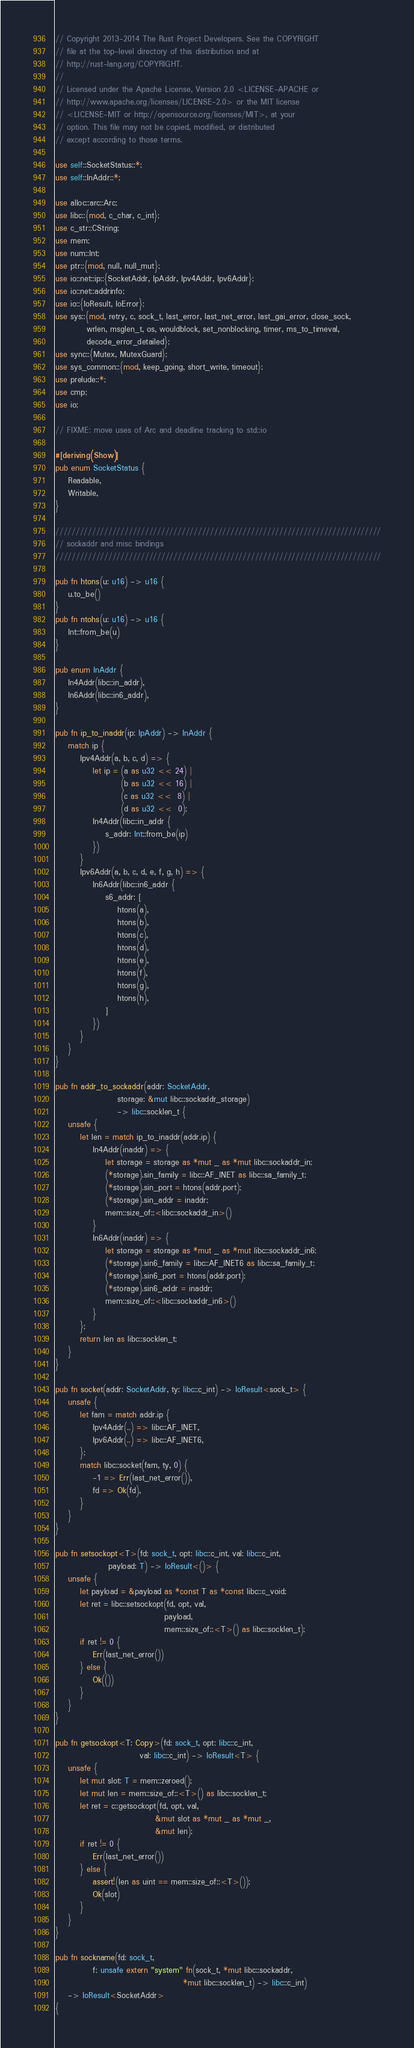<code> <loc_0><loc_0><loc_500><loc_500><_Rust_>// Copyright 2013-2014 The Rust Project Developers. See the COPYRIGHT
// file at the top-level directory of this distribution and at
// http://rust-lang.org/COPYRIGHT.
//
// Licensed under the Apache License, Version 2.0 <LICENSE-APACHE or
// http://www.apache.org/licenses/LICENSE-2.0> or the MIT license
// <LICENSE-MIT or http://opensource.org/licenses/MIT>, at your
// option. This file may not be copied, modified, or distributed
// except according to those terms.

use self::SocketStatus::*;
use self::InAddr::*;

use alloc::arc::Arc;
use libc::{mod, c_char, c_int};
use c_str::CString;
use mem;
use num::Int;
use ptr::{mod, null, null_mut};
use io::net::ip::{SocketAddr, IpAddr, Ipv4Addr, Ipv6Addr};
use io::net::addrinfo;
use io::{IoResult, IoError};
use sys::{mod, retry, c, sock_t, last_error, last_net_error, last_gai_error, close_sock,
          wrlen, msglen_t, os, wouldblock, set_nonblocking, timer, ms_to_timeval,
          decode_error_detailed};
use sync::{Mutex, MutexGuard};
use sys_common::{mod, keep_going, short_write, timeout};
use prelude::*;
use cmp;
use io;

// FIXME: move uses of Arc and deadline tracking to std::io

#[deriving(Show)]
pub enum SocketStatus {
    Readable,
    Writable,
}

////////////////////////////////////////////////////////////////////////////////
// sockaddr and misc bindings
////////////////////////////////////////////////////////////////////////////////

pub fn htons(u: u16) -> u16 {
    u.to_be()
}
pub fn ntohs(u: u16) -> u16 {
    Int::from_be(u)
}

pub enum InAddr {
    In4Addr(libc::in_addr),
    In6Addr(libc::in6_addr),
}

pub fn ip_to_inaddr(ip: IpAddr) -> InAddr {
    match ip {
        Ipv4Addr(a, b, c, d) => {
            let ip = (a as u32 << 24) |
                     (b as u32 << 16) |
                     (c as u32 <<  8) |
                     (d as u32 <<  0);
            In4Addr(libc::in_addr {
                s_addr: Int::from_be(ip)
            })
        }
        Ipv6Addr(a, b, c, d, e, f, g, h) => {
            In6Addr(libc::in6_addr {
                s6_addr: [
                    htons(a),
                    htons(b),
                    htons(c),
                    htons(d),
                    htons(e),
                    htons(f),
                    htons(g),
                    htons(h),
                ]
            })
        }
    }
}

pub fn addr_to_sockaddr(addr: SocketAddr,
                    storage: &mut libc::sockaddr_storage)
                    -> libc::socklen_t {
    unsafe {
        let len = match ip_to_inaddr(addr.ip) {
            In4Addr(inaddr) => {
                let storage = storage as *mut _ as *mut libc::sockaddr_in;
                (*storage).sin_family = libc::AF_INET as libc::sa_family_t;
                (*storage).sin_port = htons(addr.port);
                (*storage).sin_addr = inaddr;
                mem::size_of::<libc::sockaddr_in>()
            }
            In6Addr(inaddr) => {
                let storage = storage as *mut _ as *mut libc::sockaddr_in6;
                (*storage).sin6_family = libc::AF_INET6 as libc::sa_family_t;
                (*storage).sin6_port = htons(addr.port);
                (*storage).sin6_addr = inaddr;
                mem::size_of::<libc::sockaddr_in6>()
            }
        };
        return len as libc::socklen_t;
    }
}

pub fn socket(addr: SocketAddr, ty: libc::c_int) -> IoResult<sock_t> {
    unsafe {
        let fam = match addr.ip {
            Ipv4Addr(..) => libc::AF_INET,
            Ipv6Addr(..) => libc::AF_INET6,
        };
        match libc::socket(fam, ty, 0) {
            -1 => Err(last_net_error()),
            fd => Ok(fd),
        }
    }
}

pub fn setsockopt<T>(fd: sock_t, opt: libc::c_int, val: libc::c_int,
                 payload: T) -> IoResult<()> {
    unsafe {
        let payload = &payload as *const T as *const libc::c_void;
        let ret = libc::setsockopt(fd, opt, val,
                                   payload,
                                   mem::size_of::<T>() as libc::socklen_t);
        if ret != 0 {
            Err(last_net_error())
        } else {
            Ok(())
        }
    }
}

pub fn getsockopt<T: Copy>(fd: sock_t, opt: libc::c_int,
                           val: libc::c_int) -> IoResult<T> {
    unsafe {
        let mut slot: T = mem::zeroed();
        let mut len = mem::size_of::<T>() as libc::socklen_t;
        let ret = c::getsockopt(fd, opt, val,
                                &mut slot as *mut _ as *mut _,
                                &mut len);
        if ret != 0 {
            Err(last_net_error())
        } else {
            assert!(len as uint == mem::size_of::<T>());
            Ok(slot)
        }
    }
}

pub fn sockname(fd: sock_t,
            f: unsafe extern "system" fn(sock_t, *mut libc::sockaddr,
                                         *mut libc::socklen_t) -> libc::c_int)
    -> IoResult<SocketAddr>
{</code> 